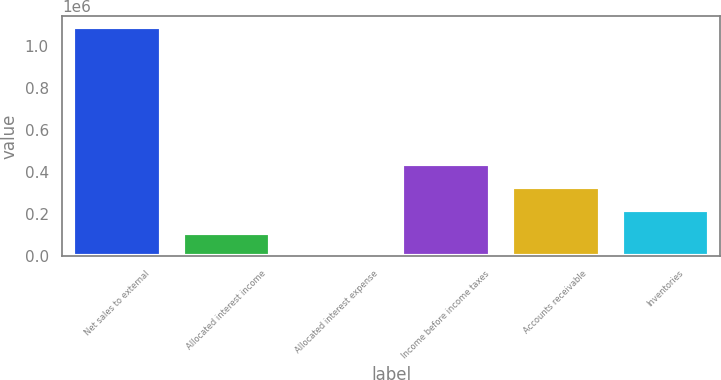<chart> <loc_0><loc_0><loc_500><loc_500><bar_chart><fcel>Net sales to external<fcel>Allocated interest income<fcel>Allocated interest expense<fcel>Income before income taxes<fcel>Accounts receivable<fcel>Inventories<nl><fcel>1.08909e+06<fcel>108966<fcel>63<fcel>435675<fcel>326772<fcel>217869<nl></chart> 